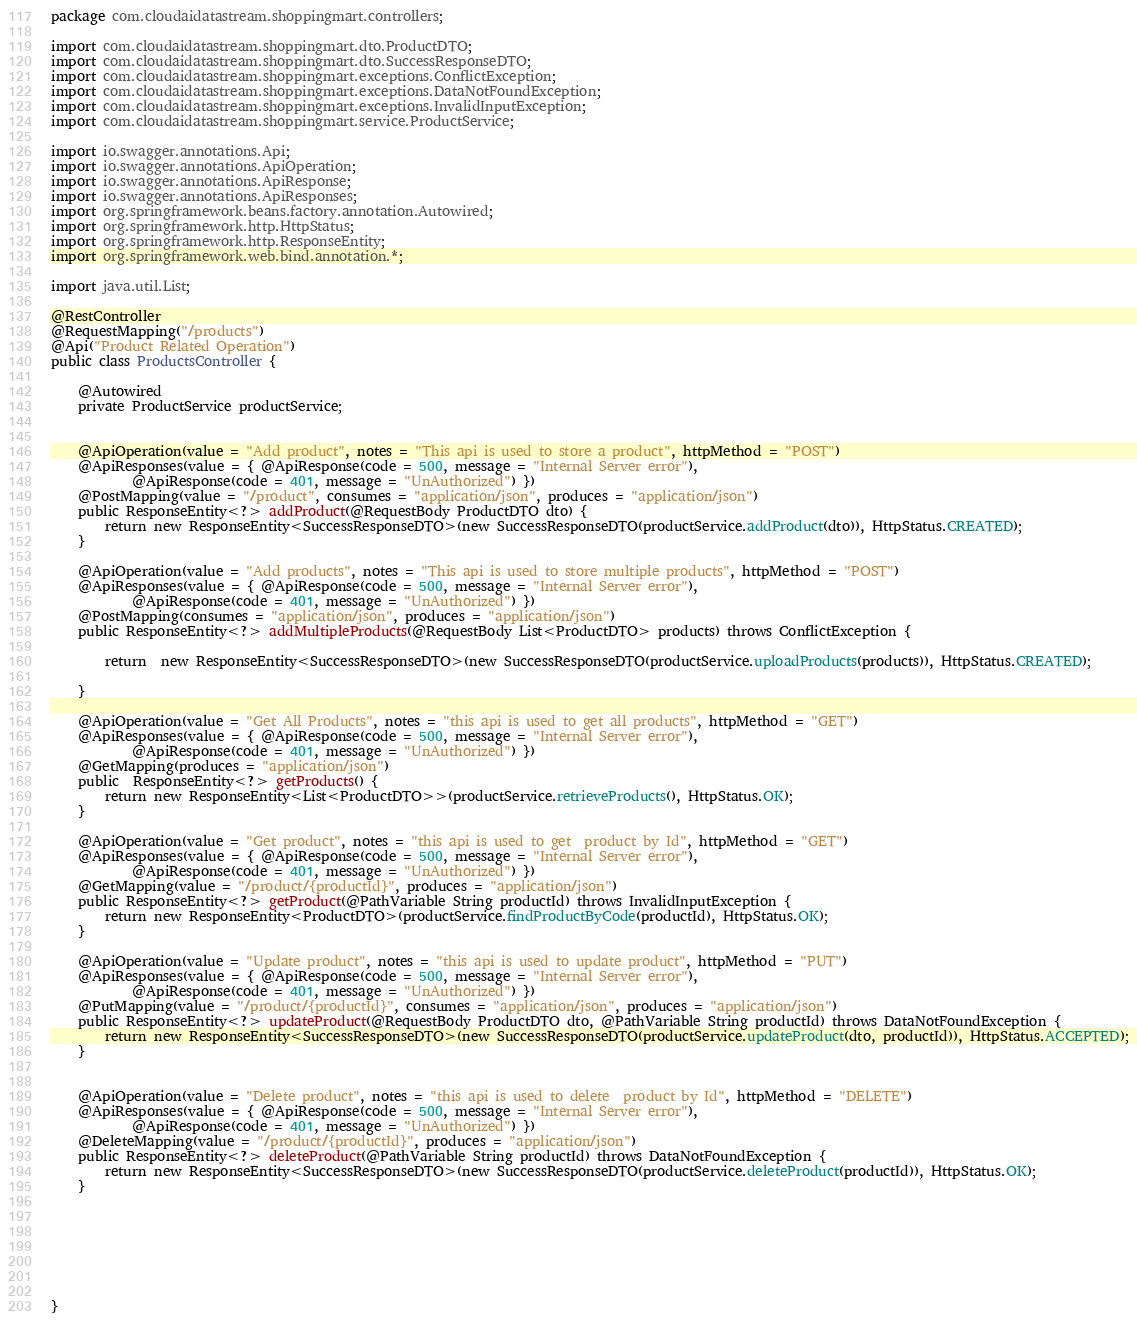<code> <loc_0><loc_0><loc_500><loc_500><_Java_>package com.cloudaidatastream.shoppingmart.controllers;

import com.cloudaidatastream.shoppingmart.dto.ProductDTO;
import com.cloudaidatastream.shoppingmart.dto.SuccessResponseDTO;
import com.cloudaidatastream.shoppingmart.exceptions.ConflictException;
import com.cloudaidatastream.shoppingmart.exceptions.DataNotFoundException;
import com.cloudaidatastream.shoppingmart.exceptions.InvalidInputException;
import com.cloudaidatastream.shoppingmart.service.ProductService;

import io.swagger.annotations.Api;
import io.swagger.annotations.ApiOperation;
import io.swagger.annotations.ApiResponse;
import io.swagger.annotations.ApiResponses;
import org.springframework.beans.factory.annotation.Autowired;
import org.springframework.http.HttpStatus;
import org.springframework.http.ResponseEntity;
import org.springframework.web.bind.annotation.*;

import java.util.List;

@RestController
@RequestMapping("/products")
@Api("Product Related Operation")
public class ProductsController {

    @Autowired
    private ProductService productService;


    @ApiOperation(value = "Add product", notes = "This api is used to store a product", httpMethod = "POST")
    @ApiResponses(value = { @ApiResponse(code = 500, message = "Internal Server error"),
            @ApiResponse(code = 401, message = "UnAuthorized") })
    @PostMapping(value = "/product", consumes = "application/json", produces = "application/json")
    public ResponseEntity<?> addProduct(@RequestBody ProductDTO dto) {
        return new ResponseEntity<SuccessResponseDTO>(new SuccessResponseDTO(productService.addProduct(dto)), HttpStatus.CREATED);
    }

    @ApiOperation(value = "Add products", notes = "This api is used to store multiple products", httpMethod = "POST")
    @ApiResponses(value = { @ApiResponse(code = 500, message = "Internal Server error"),
            @ApiResponse(code = 401, message = "UnAuthorized") })
    @PostMapping(consumes = "application/json", produces = "application/json")
    public ResponseEntity<?> addMultipleProducts(@RequestBody List<ProductDTO> products) throws ConflictException {

        return  new ResponseEntity<SuccessResponseDTO>(new SuccessResponseDTO(productService.uploadProducts(products)), HttpStatus.CREATED);

    }

    @ApiOperation(value = "Get All Products", notes = "this api is used to get all products", httpMethod = "GET")
    @ApiResponses(value = { @ApiResponse(code = 500, message = "Internal Server error"),
            @ApiResponse(code = 401, message = "UnAuthorized") })
    @GetMapping(produces = "application/json")
    public  ResponseEntity<?> getProducts() {
        return new ResponseEntity<List<ProductDTO>>(productService.retrieveProducts(), HttpStatus.OK);
    }

    @ApiOperation(value = "Get product", notes = "this api is used to get  product by Id", httpMethod = "GET")
    @ApiResponses(value = { @ApiResponse(code = 500, message = "Internal Server error"),
            @ApiResponse(code = 401, message = "UnAuthorized") })
    @GetMapping(value = "/product/{productId}", produces = "application/json")
    public ResponseEntity<?> getProduct(@PathVariable String productId) throws InvalidInputException {
        return new ResponseEntity<ProductDTO>(productService.findProductByCode(productId), HttpStatus.OK);
    }

    @ApiOperation(value = "Update product", notes = "this api is used to update product", httpMethod = "PUT")
    @ApiResponses(value = { @ApiResponse(code = 500, message = "Internal Server error"),
            @ApiResponse(code = 401, message = "UnAuthorized") })
    @PutMapping(value = "/product/{productId}", consumes = "application/json", produces = "application/json")
    public ResponseEntity<?> updateProduct(@RequestBody ProductDTO dto, @PathVariable String productId) throws DataNotFoundException {
        return new ResponseEntity<SuccessResponseDTO>(new SuccessResponseDTO(productService.updateProduct(dto, productId)), HttpStatus.ACCEPTED);
    }


    @ApiOperation(value = "Delete product", notes = "this api is used to delete  product by Id", httpMethod = "DELETE")
    @ApiResponses(value = { @ApiResponse(code = 500, message = "Internal Server error"),
            @ApiResponse(code = 401, message = "UnAuthorized") })
    @DeleteMapping(value = "/product/{productId}", produces = "application/json")
    public ResponseEntity<?> deleteProduct(@PathVariable String productId) throws DataNotFoundException {
        return new ResponseEntity<SuccessResponseDTO>(new SuccessResponseDTO(productService.deleteProduct(productId)), HttpStatus.OK);
    }







}
</code> 